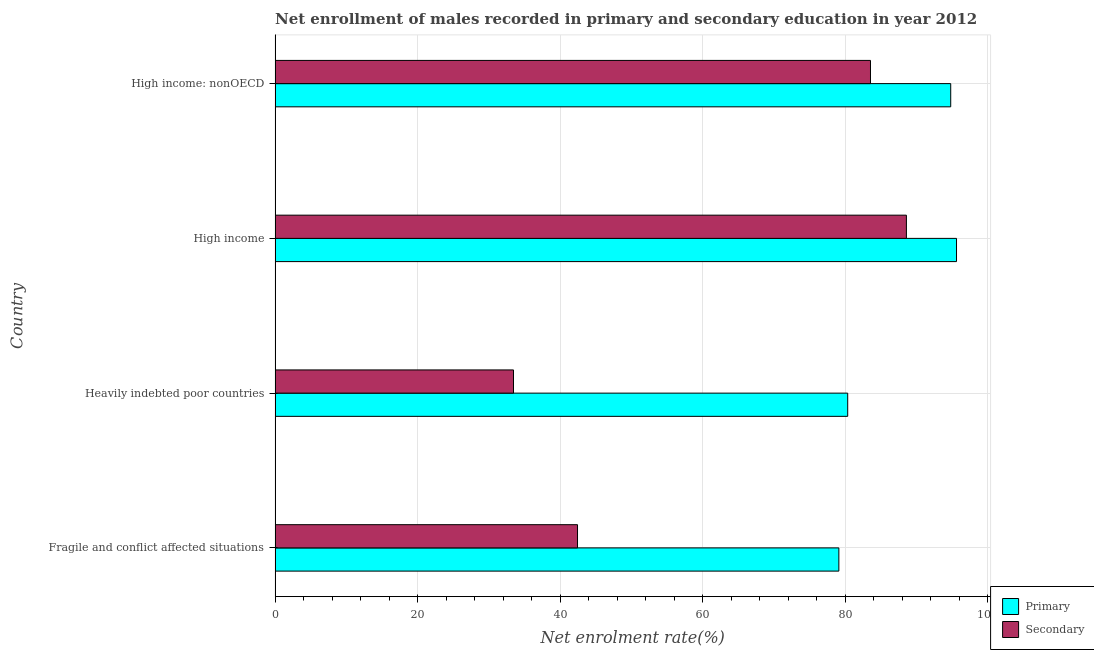How many groups of bars are there?
Your answer should be compact. 4. How many bars are there on the 4th tick from the bottom?
Your answer should be compact. 2. What is the label of the 3rd group of bars from the top?
Your answer should be very brief. Heavily indebted poor countries. In how many cases, is the number of bars for a given country not equal to the number of legend labels?
Keep it short and to the point. 0. What is the enrollment rate in secondary education in High income?
Offer a very short reply. 88.58. Across all countries, what is the maximum enrollment rate in secondary education?
Keep it short and to the point. 88.58. Across all countries, what is the minimum enrollment rate in primary education?
Provide a succinct answer. 79.1. In which country was the enrollment rate in primary education maximum?
Make the answer very short. High income. In which country was the enrollment rate in primary education minimum?
Your response must be concise. Fragile and conflict affected situations. What is the total enrollment rate in primary education in the graph?
Offer a terse response. 349.86. What is the difference between the enrollment rate in primary education in High income and that in High income: nonOECD?
Make the answer very short. 0.81. What is the difference between the enrollment rate in secondary education in Heavily indebted poor countries and the enrollment rate in primary education in High income: nonOECD?
Your answer should be very brief. -61.35. What is the average enrollment rate in primary education per country?
Keep it short and to the point. 87.47. What is the difference between the enrollment rate in secondary education and enrollment rate in primary education in High income: nonOECD?
Provide a short and direct response. -11.26. What is the ratio of the enrollment rate in secondary education in Heavily indebted poor countries to that in High income?
Your answer should be very brief. 0.38. Is the difference between the enrollment rate in primary education in High income and High income: nonOECD greater than the difference between the enrollment rate in secondary education in High income and High income: nonOECD?
Ensure brevity in your answer.  No. What is the difference between the highest and the second highest enrollment rate in primary education?
Give a very brief answer. 0.81. What is the difference between the highest and the lowest enrollment rate in secondary education?
Keep it short and to the point. 55.13. What does the 2nd bar from the top in High income represents?
Your answer should be compact. Primary. What does the 1st bar from the bottom in High income: nonOECD represents?
Offer a very short reply. Primary. How many bars are there?
Make the answer very short. 8. Are all the bars in the graph horizontal?
Make the answer very short. Yes. Are the values on the major ticks of X-axis written in scientific E-notation?
Your answer should be very brief. No. Does the graph contain grids?
Offer a very short reply. Yes. How many legend labels are there?
Give a very brief answer. 2. How are the legend labels stacked?
Provide a short and direct response. Vertical. What is the title of the graph?
Ensure brevity in your answer.  Net enrollment of males recorded in primary and secondary education in year 2012. Does "Quality of trade" appear as one of the legend labels in the graph?
Your answer should be compact. No. What is the label or title of the X-axis?
Your answer should be very brief. Net enrolment rate(%). What is the label or title of the Y-axis?
Provide a short and direct response. Country. What is the Net enrolment rate(%) in Primary in Fragile and conflict affected situations?
Your response must be concise. 79.1. What is the Net enrolment rate(%) of Secondary in Fragile and conflict affected situations?
Your answer should be very brief. 42.44. What is the Net enrolment rate(%) in Primary in Heavily indebted poor countries?
Offer a terse response. 80.34. What is the Net enrolment rate(%) in Secondary in Heavily indebted poor countries?
Offer a very short reply. 33.45. What is the Net enrolment rate(%) of Primary in High income?
Offer a terse response. 95.61. What is the Net enrolment rate(%) in Secondary in High income?
Offer a very short reply. 88.58. What is the Net enrolment rate(%) of Primary in High income: nonOECD?
Your answer should be compact. 94.8. What is the Net enrolment rate(%) in Secondary in High income: nonOECD?
Offer a terse response. 83.54. Across all countries, what is the maximum Net enrolment rate(%) of Primary?
Make the answer very short. 95.61. Across all countries, what is the maximum Net enrolment rate(%) of Secondary?
Make the answer very short. 88.58. Across all countries, what is the minimum Net enrolment rate(%) in Primary?
Offer a very short reply. 79.1. Across all countries, what is the minimum Net enrolment rate(%) of Secondary?
Offer a terse response. 33.45. What is the total Net enrolment rate(%) of Primary in the graph?
Provide a short and direct response. 349.86. What is the total Net enrolment rate(%) in Secondary in the graph?
Provide a succinct answer. 248.01. What is the difference between the Net enrolment rate(%) of Primary in Fragile and conflict affected situations and that in Heavily indebted poor countries?
Give a very brief answer. -1.24. What is the difference between the Net enrolment rate(%) of Secondary in Fragile and conflict affected situations and that in Heavily indebted poor countries?
Keep it short and to the point. 8.98. What is the difference between the Net enrolment rate(%) in Primary in Fragile and conflict affected situations and that in High income?
Your answer should be very brief. -16.51. What is the difference between the Net enrolment rate(%) in Secondary in Fragile and conflict affected situations and that in High income?
Your answer should be compact. -46.15. What is the difference between the Net enrolment rate(%) of Primary in Fragile and conflict affected situations and that in High income: nonOECD?
Provide a succinct answer. -15.7. What is the difference between the Net enrolment rate(%) of Secondary in Fragile and conflict affected situations and that in High income: nonOECD?
Your answer should be compact. -41.11. What is the difference between the Net enrolment rate(%) in Primary in Heavily indebted poor countries and that in High income?
Ensure brevity in your answer.  -15.27. What is the difference between the Net enrolment rate(%) of Secondary in Heavily indebted poor countries and that in High income?
Provide a succinct answer. -55.13. What is the difference between the Net enrolment rate(%) in Primary in Heavily indebted poor countries and that in High income: nonOECD?
Ensure brevity in your answer.  -14.46. What is the difference between the Net enrolment rate(%) of Secondary in Heavily indebted poor countries and that in High income: nonOECD?
Your answer should be very brief. -50.09. What is the difference between the Net enrolment rate(%) in Primary in High income and that in High income: nonOECD?
Keep it short and to the point. 0.81. What is the difference between the Net enrolment rate(%) of Secondary in High income and that in High income: nonOECD?
Ensure brevity in your answer.  5.04. What is the difference between the Net enrolment rate(%) of Primary in Fragile and conflict affected situations and the Net enrolment rate(%) of Secondary in Heavily indebted poor countries?
Your answer should be very brief. 45.65. What is the difference between the Net enrolment rate(%) of Primary in Fragile and conflict affected situations and the Net enrolment rate(%) of Secondary in High income?
Give a very brief answer. -9.48. What is the difference between the Net enrolment rate(%) of Primary in Fragile and conflict affected situations and the Net enrolment rate(%) of Secondary in High income: nonOECD?
Ensure brevity in your answer.  -4.44. What is the difference between the Net enrolment rate(%) in Primary in Heavily indebted poor countries and the Net enrolment rate(%) in Secondary in High income?
Your answer should be compact. -8.24. What is the difference between the Net enrolment rate(%) of Primary in Heavily indebted poor countries and the Net enrolment rate(%) of Secondary in High income: nonOECD?
Your response must be concise. -3.2. What is the difference between the Net enrolment rate(%) of Primary in High income and the Net enrolment rate(%) of Secondary in High income: nonOECD?
Your answer should be very brief. 12.07. What is the average Net enrolment rate(%) of Primary per country?
Provide a short and direct response. 87.47. What is the average Net enrolment rate(%) of Secondary per country?
Your answer should be compact. 62. What is the difference between the Net enrolment rate(%) of Primary and Net enrolment rate(%) of Secondary in Fragile and conflict affected situations?
Your answer should be compact. 36.67. What is the difference between the Net enrolment rate(%) of Primary and Net enrolment rate(%) of Secondary in Heavily indebted poor countries?
Your answer should be compact. 46.89. What is the difference between the Net enrolment rate(%) of Primary and Net enrolment rate(%) of Secondary in High income?
Your answer should be very brief. 7.03. What is the difference between the Net enrolment rate(%) of Primary and Net enrolment rate(%) of Secondary in High income: nonOECD?
Offer a terse response. 11.26. What is the ratio of the Net enrolment rate(%) of Primary in Fragile and conflict affected situations to that in Heavily indebted poor countries?
Give a very brief answer. 0.98. What is the ratio of the Net enrolment rate(%) of Secondary in Fragile and conflict affected situations to that in Heavily indebted poor countries?
Ensure brevity in your answer.  1.27. What is the ratio of the Net enrolment rate(%) in Primary in Fragile and conflict affected situations to that in High income?
Your answer should be compact. 0.83. What is the ratio of the Net enrolment rate(%) of Secondary in Fragile and conflict affected situations to that in High income?
Keep it short and to the point. 0.48. What is the ratio of the Net enrolment rate(%) of Primary in Fragile and conflict affected situations to that in High income: nonOECD?
Offer a terse response. 0.83. What is the ratio of the Net enrolment rate(%) in Secondary in Fragile and conflict affected situations to that in High income: nonOECD?
Make the answer very short. 0.51. What is the ratio of the Net enrolment rate(%) in Primary in Heavily indebted poor countries to that in High income?
Your answer should be compact. 0.84. What is the ratio of the Net enrolment rate(%) in Secondary in Heavily indebted poor countries to that in High income?
Provide a short and direct response. 0.38. What is the ratio of the Net enrolment rate(%) of Primary in Heavily indebted poor countries to that in High income: nonOECD?
Ensure brevity in your answer.  0.85. What is the ratio of the Net enrolment rate(%) in Secondary in Heavily indebted poor countries to that in High income: nonOECD?
Your response must be concise. 0.4. What is the ratio of the Net enrolment rate(%) in Primary in High income to that in High income: nonOECD?
Keep it short and to the point. 1.01. What is the ratio of the Net enrolment rate(%) of Secondary in High income to that in High income: nonOECD?
Provide a succinct answer. 1.06. What is the difference between the highest and the second highest Net enrolment rate(%) in Primary?
Ensure brevity in your answer.  0.81. What is the difference between the highest and the second highest Net enrolment rate(%) in Secondary?
Give a very brief answer. 5.04. What is the difference between the highest and the lowest Net enrolment rate(%) of Primary?
Offer a very short reply. 16.51. What is the difference between the highest and the lowest Net enrolment rate(%) of Secondary?
Your response must be concise. 55.13. 